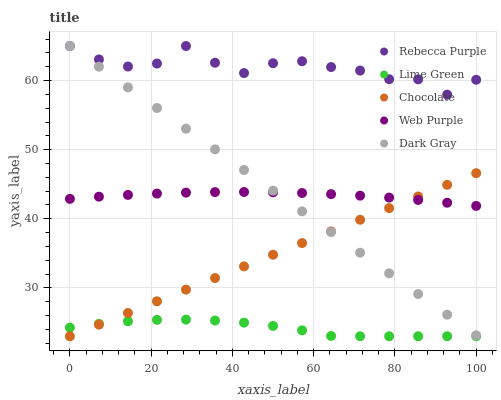Does Lime Green have the minimum area under the curve?
Answer yes or no. Yes. Does Rebecca Purple have the maximum area under the curve?
Answer yes or no. Yes. Does Web Purple have the minimum area under the curve?
Answer yes or no. No. Does Web Purple have the maximum area under the curve?
Answer yes or no. No. Is Chocolate the smoothest?
Answer yes or no. Yes. Is Rebecca Purple the roughest?
Answer yes or no. Yes. Is Web Purple the smoothest?
Answer yes or no. No. Is Web Purple the roughest?
Answer yes or no. No. Does Lime Green have the lowest value?
Answer yes or no. Yes. Does Web Purple have the lowest value?
Answer yes or no. No. Does Rebecca Purple have the highest value?
Answer yes or no. Yes. Does Web Purple have the highest value?
Answer yes or no. No. Is Web Purple less than Rebecca Purple?
Answer yes or no. Yes. Is Dark Gray greater than Lime Green?
Answer yes or no. Yes. Does Chocolate intersect Lime Green?
Answer yes or no. Yes. Is Chocolate less than Lime Green?
Answer yes or no. No. Is Chocolate greater than Lime Green?
Answer yes or no. No. Does Web Purple intersect Rebecca Purple?
Answer yes or no. No. 